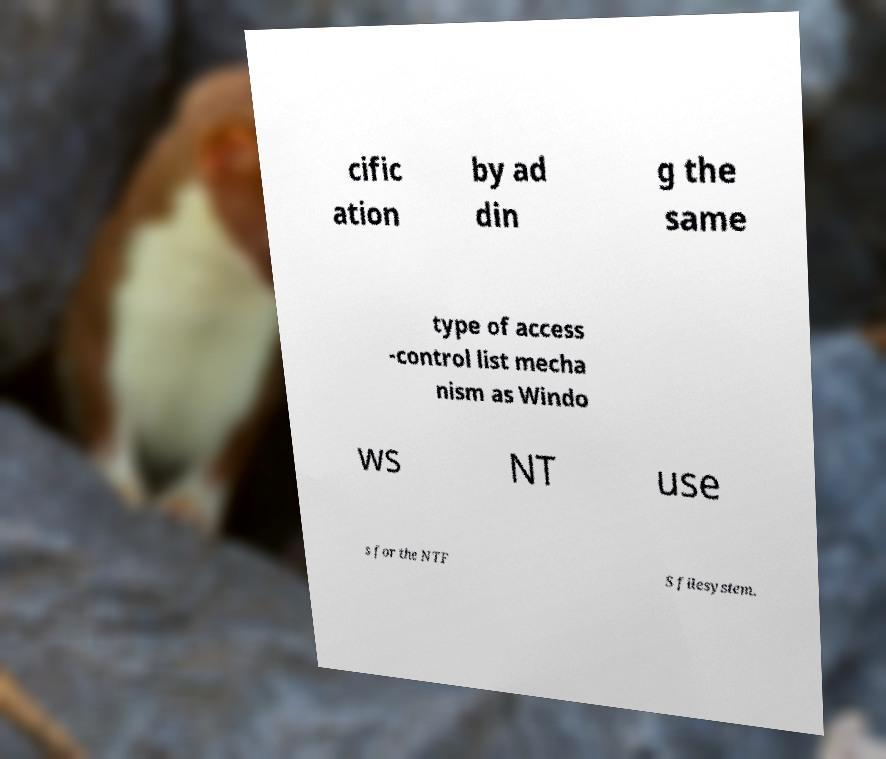There's text embedded in this image that I need extracted. Can you transcribe it verbatim? cific ation by ad din g the same type of access -control list mecha nism as Windo ws NT use s for the NTF S filesystem. 